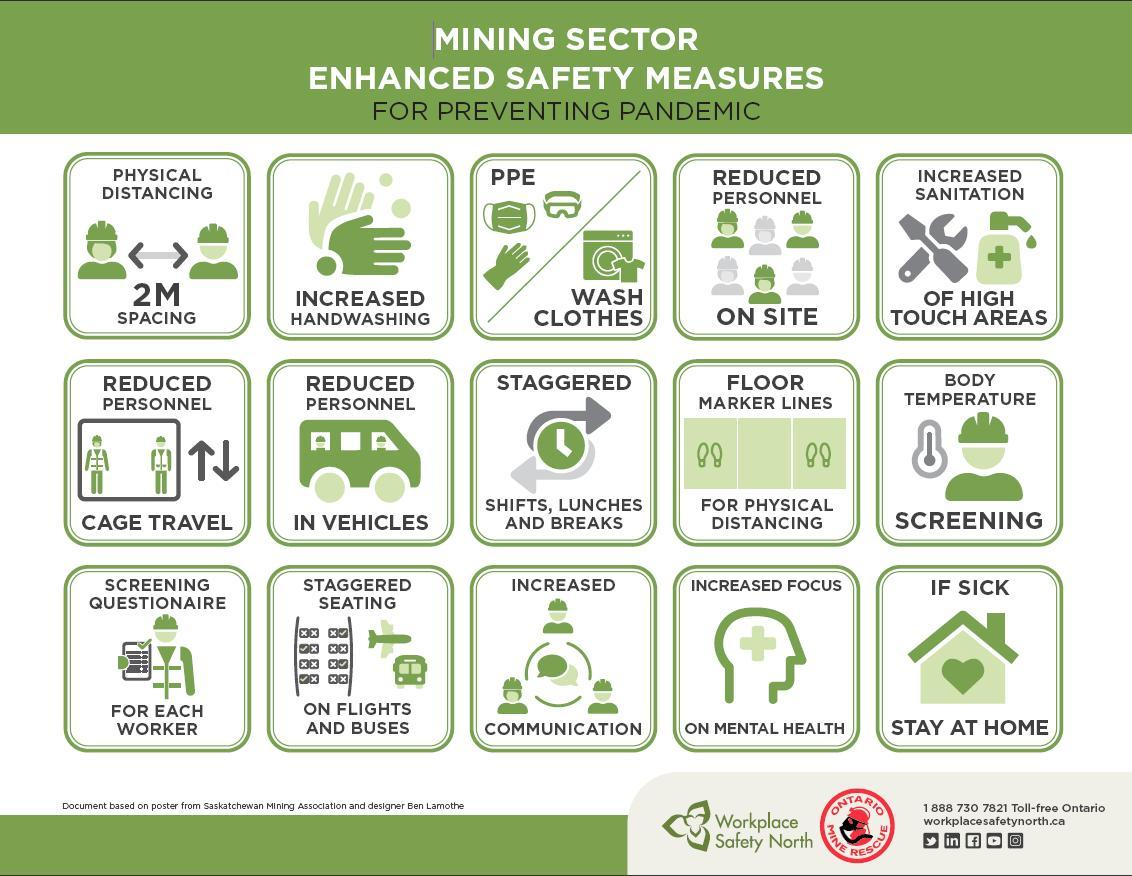What is the preventive measure taken on road and air transportation?
Answer the question with a short phrase. staggered seating What is the prevention taken on count of workers in site? Reduced Personnel What should be done when mining workers fall sick? stay at home What is the extra step taken on clothing of workers? PPE, Wash Clothes What is the prevention taken on areas with probability of more contact? Increased Sanitation What measure has been taken to maintain social distancing between workers? marker lines 